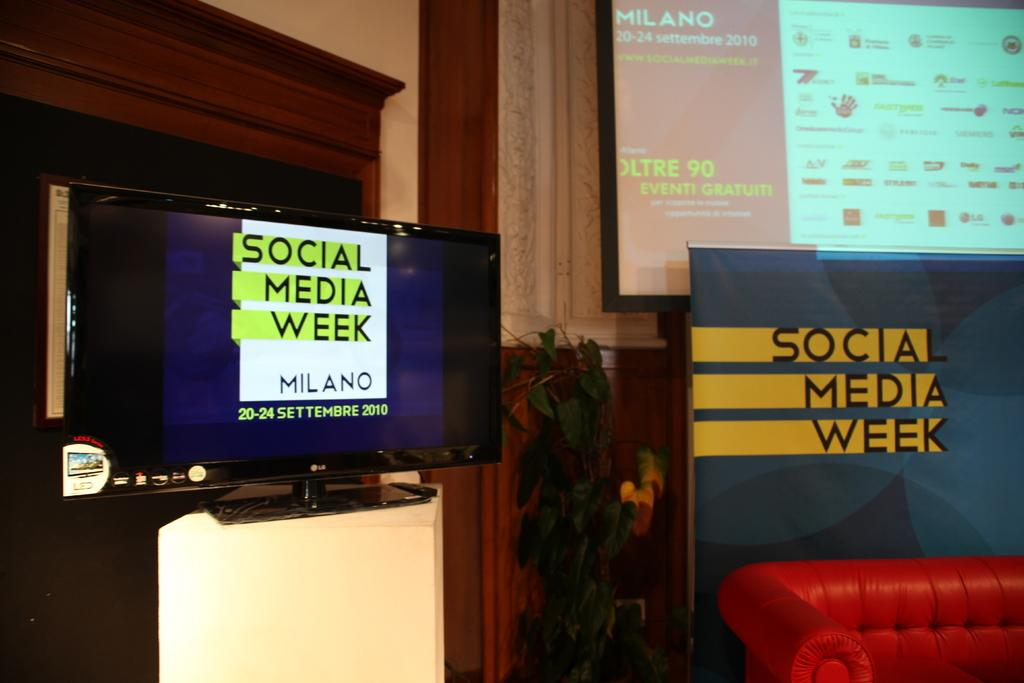How many televisions can be seen in the image? There are two televisions in the image. What type of furniture is present in the image? There is a sofa bed in the image. Are there any plants visible in the image? Yes, there is a plant in the image. What type of organization is responsible for the cloth used on the sofa bed in the image? There is no mention of cloth or any organization in the image, as it only features two televisions, a sofa bed, and a plant. 